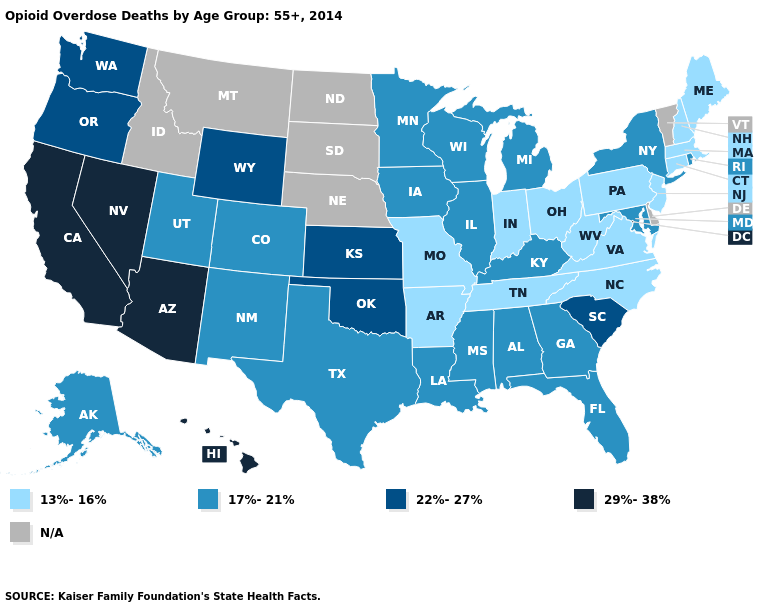What is the lowest value in states that border Maine?
Give a very brief answer. 13%-16%. What is the value of Louisiana?
Short answer required. 17%-21%. Is the legend a continuous bar?
Answer briefly. No. Name the states that have a value in the range 22%-27%?
Give a very brief answer. Kansas, Oklahoma, Oregon, South Carolina, Washington, Wyoming. What is the highest value in the MidWest ?
Write a very short answer. 22%-27%. Name the states that have a value in the range 13%-16%?
Concise answer only. Arkansas, Connecticut, Indiana, Maine, Massachusetts, Missouri, New Hampshire, New Jersey, North Carolina, Ohio, Pennsylvania, Tennessee, Virginia, West Virginia. Which states have the lowest value in the USA?
Short answer required. Arkansas, Connecticut, Indiana, Maine, Massachusetts, Missouri, New Hampshire, New Jersey, North Carolina, Ohio, Pennsylvania, Tennessee, Virginia, West Virginia. Which states hav the highest value in the South?
Short answer required. Oklahoma, South Carolina. Among the states that border Florida , which have the highest value?
Keep it brief. Alabama, Georgia. Which states have the lowest value in the USA?
Give a very brief answer. Arkansas, Connecticut, Indiana, Maine, Massachusetts, Missouri, New Hampshire, New Jersey, North Carolina, Ohio, Pennsylvania, Tennessee, Virginia, West Virginia. What is the lowest value in the USA?
Be succinct. 13%-16%. What is the highest value in the USA?
Short answer required. 29%-38%. Name the states that have a value in the range 29%-38%?
Keep it brief. Arizona, California, Hawaii, Nevada. Does Iowa have the highest value in the MidWest?
Be succinct. No. 